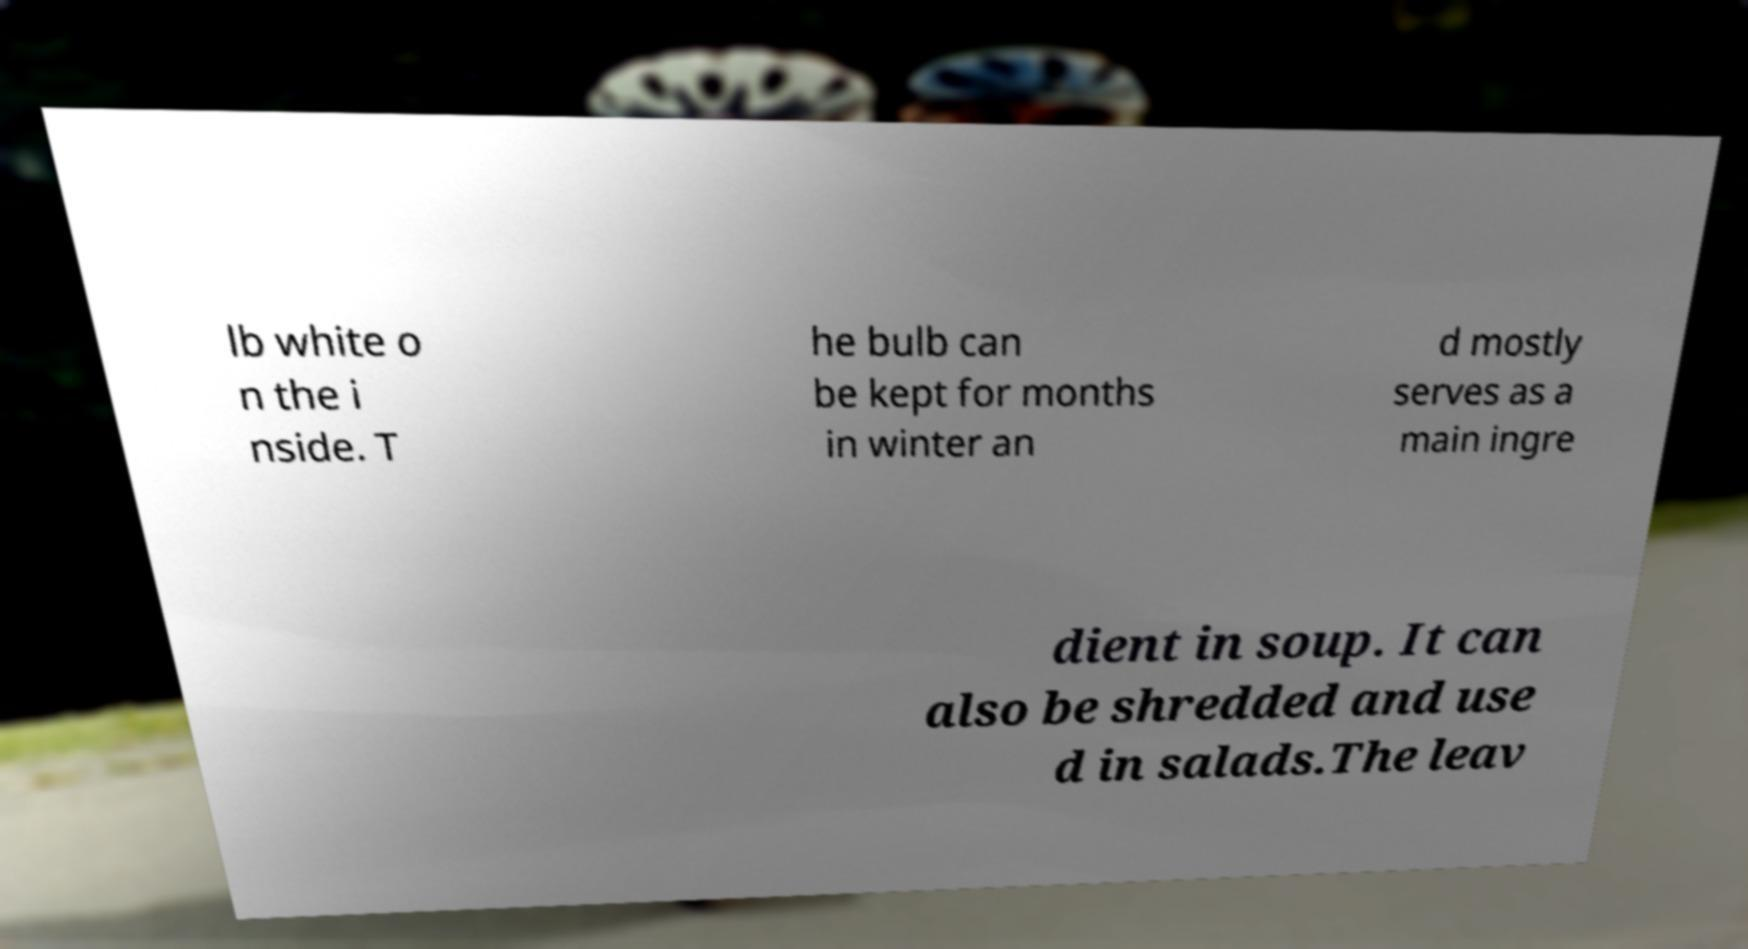Can you read and provide the text displayed in the image?This photo seems to have some interesting text. Can you extract and type it out for me? lb white o n the i nside. T he bulb can be kept for months in winter an d mostly serves as a main ingre dient in soup. It can also be shredded and use d in salads.The leav 